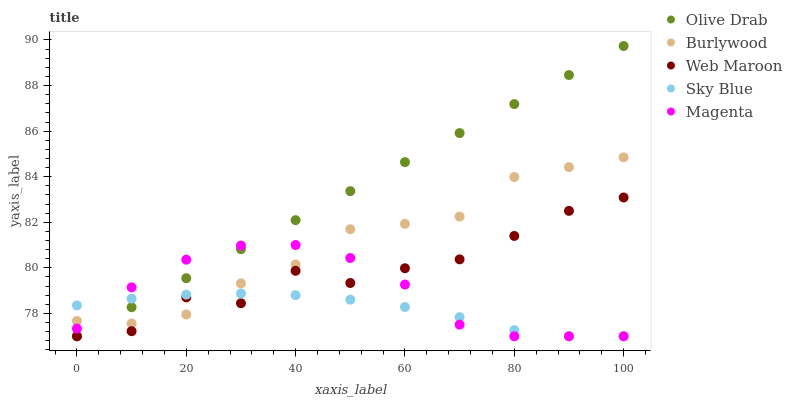Does Sky Blue have the minimum area under the curve?
Answer yes or no. Yes. Does Olive Drab have the maximum area under the curve?
Answer yes or no. Yes. Does Magenta have the minimum area under the curve?
Answer yes or no. No. Does Magenta have the maximum area under the curve?
Answer yes or no. No. Is Olive Drab the smoothest?
Answer yes or no. Yes. Is Web Maroon the roughest?
Answer yes or no. Yes. Is Sky Blue the smoothest?
Answer yes or no. No. Is Sky Blue the roughest?
Answer yes or no. No. Does Sky Blue have the lowest value?
Answer yes or no. Yes. Does Olive Drab have the highest value?
Answer yes or no. Yes. Does Magenta have the highest value?
Answer yes or no. No. Does Sky Blue intersect Burlywood?
Answer yes or no. Yes. Is Sky Blue less than Burlywood?
Answer yes or no. No. Is Sky Blue greater than Burlywood?
Answer yes or no. No. 